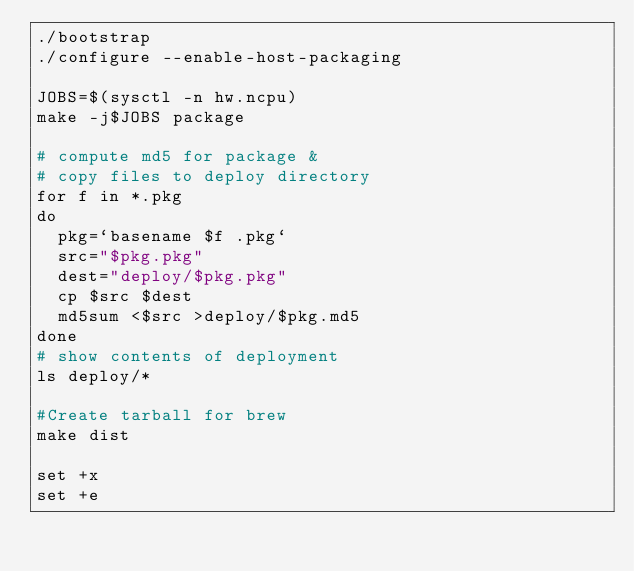Convert code to text. <code><loc_0><loc_0><loc_500><loc_500><_Bash_>./bootstrap
./configure --enable-host-packaging

JOBS=$(sysctl -n hw.ncpu)
make -j$JOBS package

# compute md5 for package &
# copy files to deploy directory
for f in *.pkg
do
  pkg=`basename $f .pkg`
  src="$pkg.pkg"
  dest="deploy/$pkg.pkg"
  cp $src $dest
  md5sum <$src >deploy/$pkg.md5
done
# show contents of deployment
ls deploy/*

#Create tarball for brew
make dist

set +x
set +e
</code> 